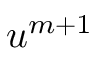<formula> <loc_0><loc_0><loc_500><loc_500>\boldsymbol u ^ { m + 1 }</formula> 